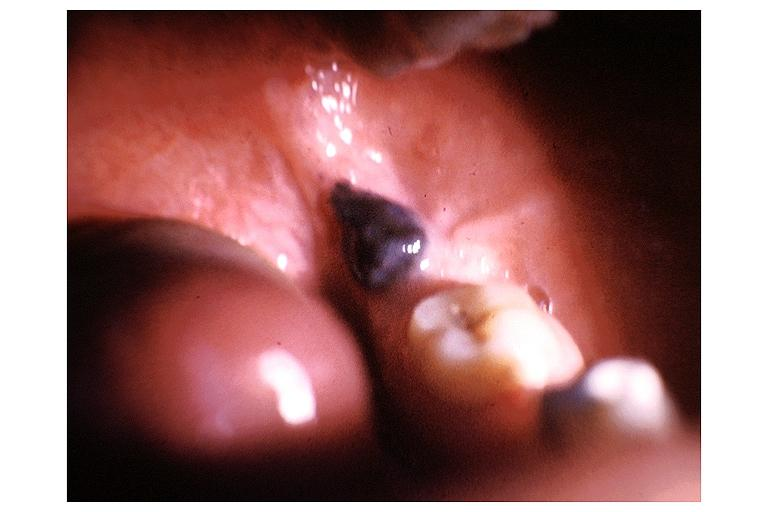s oral present?
Answer the question using a single word or phrase. Yes 